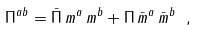<formula> <loc_0><loc_0><loc_500><loc_500>\Pi ^ { a b } = \bar { \Pi } \, m ^ { a } \, m ^ { b } + \Pi \, \bar { m } ^ { a } \, \bar { m } ^ { b } \ ,</formula> 